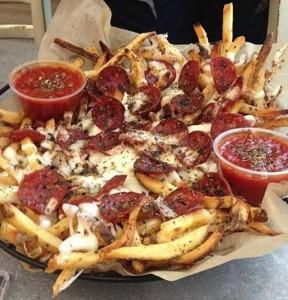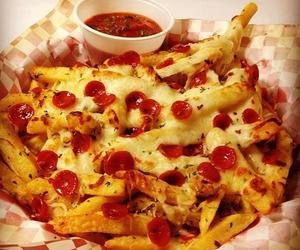The first image is the image on the left, the second image is the image on the right. Analyze the images presented: Is the assertion "The right image contains one order of pizza fries and one ramekin of marinara." valid? Answer yes or no. Yes. The first image is the image on the left, the second image is the image on the right. Analyze the images presented: Is the assertion "The left image shows a round bowl of red-orange sauce next to but not touching a rectangular pan containing french fries with pepperonis on top." valid? Answer yes or no. No. 